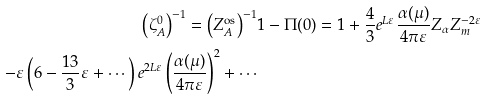Convert formula to latex. <formula><loc_0><loc_0><loc_500><loc_500>\left ( \zeta _ { A } ^ { 0 } \right ) ^ { - 1 } = \left ( Z _ { A } ^ { \text {os} } \right ) ^ { - 1 } & 1 - \Pi ( 0 ) = 1 + \frac { 4 } { 3 } e ^ { L \varepsilon } \frac { \alpha ( \mu ) } { 4 \pi \varepsilon } Z _ { \alpha } Z _ { m } ^ { - 2 \varepsilon } \\ - \varepsilon \left ( 6 - \frac { 1 3 } { 3 } \varepsilon + \cdots \right ) e ^ { 2 L \varepsilon } \left ( \frac { \alpha ( \mu ) } { 4 \pi \varepsilon } \right ) ^ { 2 } + \cdots</formula> 